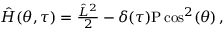Convert formula to latex. <formula><loc_0><loc_0><loc_500><loc_500>\begin{array} { r } { \hat { H } ( \theta , \tau ) = \frac { \hat { L } ^ { 2 } } { 2 } - \delta ( \tau ) P \cos ^ { 2 } ( \theta ) \, , } \end{array}</formula> 